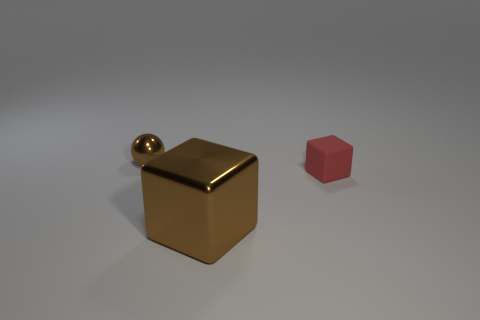Add 3 small brown shiny objects. How many objects exist? 6 Subtract all cubes. How many objects are left? 1 Add 1 red matte blocks. How many red matte blocks are left? 2 Add 3 small purple objects. How many small purple objects exist? 3 Subtract 0 green blocks. How many objects are left? 3 Subtract all large blocks. Subtract all brown metallic objects. How many objects are left? 0 